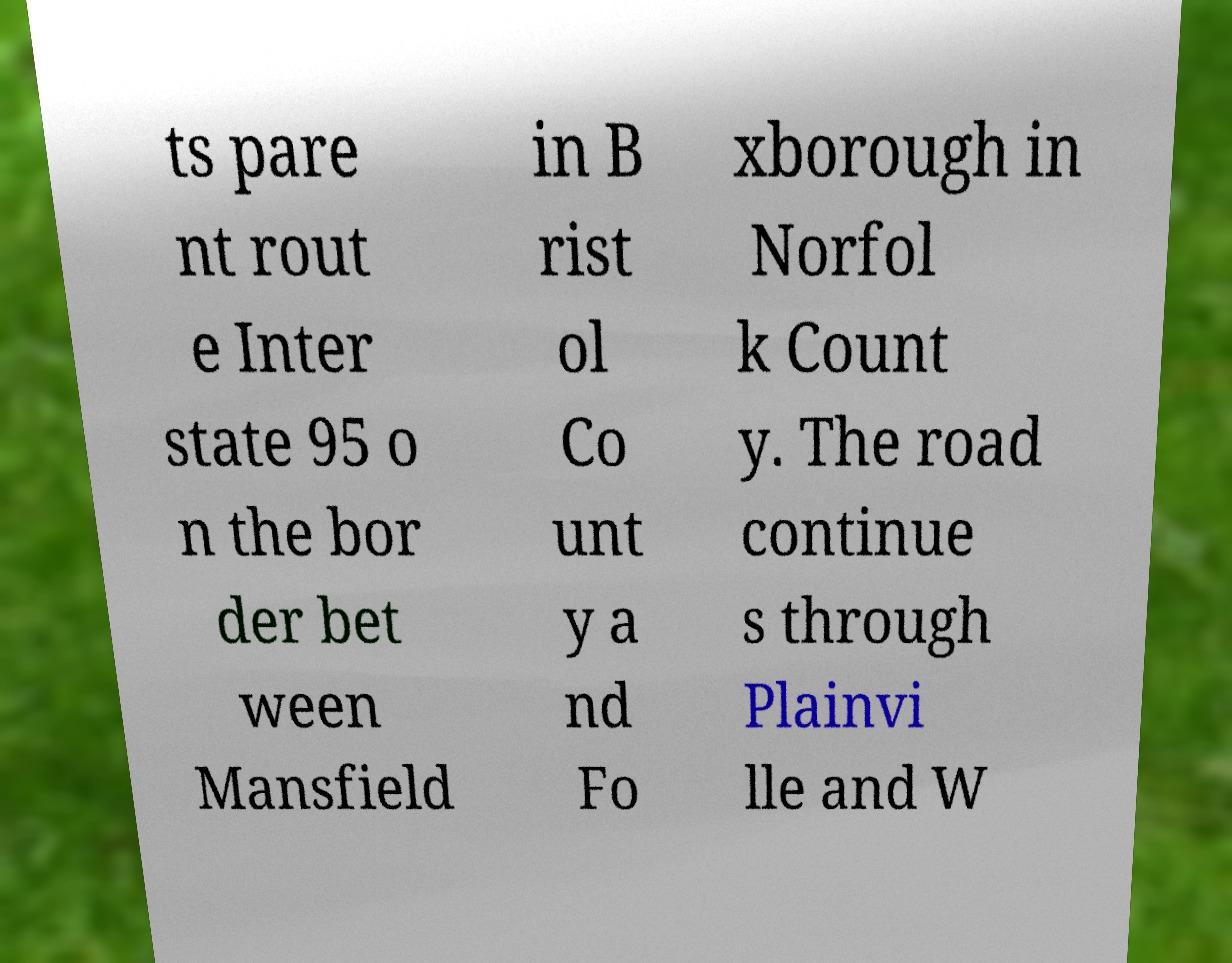Could you assist in decoding the text presented in this image and type it out clearly? ts pare nt rout e Inter state 95 o n the bor der bet ween Mansfield in B rist ol Co unt y a nd Fo xborough in Norfol k Count y. The road continue s through Plainvi lle and W 